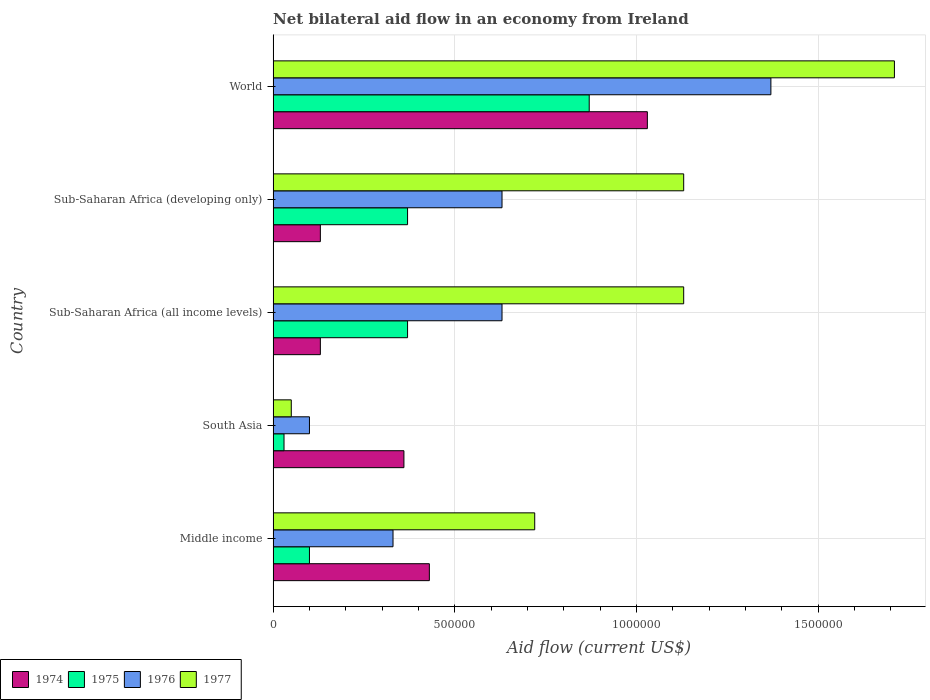How many bars are there on the 3rd tick from the top?
Keep it short and to the point. 4. In how many cases, is the number of bars for a given country not equal to the number of legend labels?
Make the answer very short. 0. What is the net bilateral aid flow in 1974 in World?
Offer a very short reply. 1.03e+06. Across all countries, what is the maximum net bilateral aid flow in 1976?
Offer a very short reply. 1.37e+06. Across all countries, what is the minimum net bilateral aid flow in 1974?
Offer a terse response. 1.30e+05. In which country was the net bilateral aid flow in 1976 maximum?
Ensure brevity in your answer.  World. In which country was the net bilateral aid flow in 1974 minimum?
Give a very brief answer. Sub-Saharan Africa (all income levels). What is the total net bilateral aid flow in 1974 in the graph?
Provide a short and direct response. 2.08e+06. What is the difference between the net bilateral aid flow in 1974 in South Asia and that in World?
Your response must be concise. -6.70e+05. What is the difference between the net bilateral aid flow in 1976 in South Asia and the net bilateral aid flow in 1975 in World?
Ensure brevity in your answer.  -7.70e+05. What is the average net bilateral aid flow in 1975 per country?
Ensure brevity in your answer.  3.48e+05. In how many countries, is the net bilateral aid flow in 1974 greater than 1500000 US$?
Offer a very short reply. 0. What is the ratio of the net bilateral aid flow in 1976 in Sub-Saharan Africa (all income levels) to that in Sub-Saharan Africa (developing only)?
Your answer should be very brief. 1. Is the difference between the net bilateral aid flow in 1977 in Sub-Saharan Africa (all income levels) and Sub-Saharan Africa (developing only) greater than the difference between the net bilateral aid flow in 1976 in Sub-Saharan Africa (all income levels) and Sub-Saharan Africa (developing only)?
Keep it short and to the point. No. What is the difference between the highest and the second highest net bilateral aid flow in 1977?
Your answer should be compact. 5.80e+05. What is the difference between the highest and the lowest net bilateral aid flow in 1977?
Your response must be concise. 1.66e+06. In how many countries, is the net bilateral aid flow in 1974 greater than the average net bilateral aid flow in 1974 taken over all countries?
Ensure brevity in your answer.  2. Is the sum of the net bilateral aid flow in 1976 in South Asia and World greater than the maximum net bilateral aid flow in 1977 across all countries?
Give a very brief answer. No. Is it the case that in every country, the sum of the net bilateral aid flow in 1976 and net bilateral aid flow in 1975 is greater than the sum of net bilateral aid flow in 1974 and net bilateral aid flow in 1977?
Provide a short and direct response. No. What does the 2nd bar from the top in Middle income represents?
Keep it short and to the point. 1976. Are all the bars in the graph horizontal?
Ensure brevity in your answer.  Yes. What is the difference between two consecutive major ticks on the X-axis?
Your response must be concise. 5.00e+05. Are the values on the major ticks of X-axis written in scientific E-notation?
Your answer should be very brief. No. Where does the legend appear in the graph?
Your answer should be very brief. Bottom left. What is the title of the graph?
Make the answer very short. Net bilateral aid flow in an economy from Ireland. Does "1981" appear as one of the legend labels in the graph?
Offer a terse response. No. What is the Aid flow (current US$) in 1976 in Middle income?
Give a very brief answer. 3.30e+05. What is the Aid flow (current US$) in 1977 in Middle income?
Keep it short and to the point. 7.20e+05. What is the Aid flow (current US$) of 1975 in South Asia?
Ensure brevity in your answer.  3.00e+04. What is the Aid flow (current US$) in 1976 in South Asia?
Provide a short and direct response. 1.00e+05. What is the Aid flow (current US$) in 1977 in South Asia?
Keep it short and to the point. 5.00e+04. What is the Aid flow (current US$) of 1974 in Sub-Saharan Africa (all income levels)?
Offer a terse response. 1.30e+05. What is the Aid flow (current US$) of 1976 in Sub-Saharan Africa (all income levels)?
Make the answer very short. 6.30e+05. What is the Aid flow (current US$) in 1977 in Sub-Saharan Africa (all income levels)?
Your answer should be very brief. 1.13e+06. What is the Aid flow (current US$) in 1976 in Sub-Saharan Africa (developing only)?
Ensure brevity in your answer.  6.30e+05. What is the Aid flow (current US$) of 1977 in Sub-Saharan Africa (developing only)?
Your answer should be very brief. 1.13e+06. What is the Aid flow (current US$) of 1974 in World?
Keep it short and to the point. 1.03e+06. What is the Aid flow (current US$) in 1975 in World?
Your answer should be compact. 8.70e+05. What is the Aid flow (current US$) in 1976 in World?
Provide a succinct answer. 1.37e+06. What is the Aid flow (current US$) in 1977 in World?
Your answer should be compact. 1.71e+06. Across all countries, what is the maximum Aid flow (current US$) in 1974?
Make the answer very short. 1.03e+06. Across all countries, what is the maximum Aid flow (current US$) of 1975?
Make the answer very short. 8.70e+05. Across all countries, what is the maximum Aid flow (current US$) of 1976?
Make the answer very short. 1.37e+06. Across all countries, what is the maximum Aid flow (current US$) of 1977?
Provide a short and direct response. 1.71e+06. What is the total Aid flow (current US$) in 1974 in the graph?
Offer a terse response. 2.08e+06. What is the total Aid flow (current US$) of 1975 in the graph?
Offer a terse response. 1.74e+06. What is the total Aid flow (current US$) of 1976 in the graph?
Your response must be concise. 3.06e+06. What is the total Aid flow (current US$) in 1977 in the graph?
Keep it short and to the point. 4.74e+06. What is the difference between the Aid flow (current US$) of 1976 in Middle income and that in South Asia?
Offer a terse response. 2.30e+05. What is the difference between the Aid flow (current US$) of 1977 in Middle income and that in South Asia?
Provide a short and direct response. 6.70e+05. What is the difference between the Aid flow (current US$) in 1974 in Middle income and that in Sub-Saharan Africa (all income levels)?
Your response must be concise. 3.00e+05. What is the difference between the Aid flow (current US$) of 1977 in Middle income and that in Sub-Saharan Africa (all income levels)?
Your answer should be very brief. -4.10e+05. What is the difference between the Aid flow (current US$) in 1977 in Middle income and that in Sub-Saharan Africa (developing only)?
Provide a short and direct response. -4.10e+05. What is the difference between the Aid flow (current US$) of 1974 in Middle income and that in World?
Your answer should be very brief. -6.00e+05. What is the difference between the Aid flow (current US$) of 1975 in Middle income and that in World?
Give a very brief answer. -7.70e+05. What is the difference between the Aid flow (current US$) in 1976 in Middle income and that in World?
Offer a very short reply. -1.04e+06. What is the difference between the Aid flow (current US$) in 1977 in Middle income and that in World?
Provide a succinct answer. -9.90e+05. What is the difference between the Aid flow (current US$) of 1976 in South Asia and that in Sub-Saharan Africa (all income levels)?
Offer a very short reply. -5.30e+05. What is the difference between the Aid flow (current US$) of 1977 in South Asia and that in Sub-Saharan Africa (all income levels)?
Provide a short and direct response. -1.08e+06. What is the difference between the Aid flow (current US$) of 1974 in South Asia and that in Sub-Saharan Africa (developing only)?
Offer a very short reply. 2.30e+05. What is the difference between the Aid flow (current US$) in 1975 in South Asia and that in Sub-Saharan Africa (developing only)?
Your answer should be very brief. -3.40e+05. What is the difference between the Aid flow (current US$) in 1976 in South Asia and that in Sub-Saharan Africa (developing only)?
Your answer should be compact. -5.30e+05. What is the difference between the Aid flow (current US$) in 1977 in South Asia and that in Sub-Saharan Africa (developing only)?
Provide a short and direct response. -1.08e+06. What is the difference between the Aid flow (current US$) of 1974 in South Asia and that in World?
Make the answer very short. -6.70e+05. What is the difference between the Aid flow (current US$) in 1975 in South Asia and that in World?
Provide a succinct answer. -8.40e+05. What is the difference between the Aid flow (current US$) in 1976 in South Asia and that in World?
Offer a terse response. -1.27e+06. What is the difference between the Aid flow (current US$) of 1977 in South Asia and that in World?
Give a very brief answer. -1.66e+06. What is the difference between the Aid flow (current US$) in 1974 in Sub-Saharan Africa (all income levels) and that in Sub-Saharan Africa (developing only)?
Your answer should be compact. 0. What is the difference between the Aid flow (current US$) of 1974 in Sub-Saharan Africa (all income levels) and that in World?
Offer a terse response. -9.00e+05. What is the difference between the Aid flow (current US$) in 1975 in Sub-Saharan Africa (all income levels) and that in World?
Provide a succinct answer. -5.00e+05. What is the difference between the Aid flow (current US$) in 1976 in Sub-Saharan Africa (all income levels) and that in World?
Your answer should be very brief. -7.40e+05. What is the difference between the Aid flow (current US$) in 1977 in Sub-Saharan Africa (all income levels) and that in World?
Keep it short and to the point. -5.80e+05. What is the difference between the Aid flow (current US$) of 1974 in Sub-Saharan Africa (developing only) and that in World?
Give a very brief answer. -9.00e+05. What is the difference between the Aid flow (current US$) of 1975 in Sub-Saharan Africa (developing only) and that in World?
Offer a terse response. -5.00e+05. What is the difference between the Aid flow (current US$) of 1976 in Sub-Saharan Africa (developing only) and that in World?
Keep it short and to the point. -7.40e+05. What is the difference between the Aid flow (current US$) in 1977 in Sub-Saharan Africa (developing only) and that in World?
Make the answer very short. -5.80e+05. What is the difference between the Aid flow (current US$) in 1974 in Middle income and the Aid flow (current US$) in 1975 in South Asia?
Give a very brief answer. 4.00e+05. What is the difference between the Aid flow (current US$) in 1975 in Middle income and the Aid flow (current US$) in 1977 in South Asia?
Your response must be concise. 5.00e+04. What is the difference between the Aid flow (current US$) in 1976 in Middle income and the Aid flow (current US$) in 1977 in South Asia?
Keep it short and to the point. 2.80e+05. What is the difference between the Aid flow (current US$) in 1974 in Middle income and the Aid flow (current US$) in 1975 in Sub-Saharan Africa (all income levels)?
Provide a short and direct response. 6.00e+04. What is the difference between the Aid flow (current US$) in 1974 in Middle income and the Aid flow (current US$) in 1976 in Sub-Saharan Africa (all income levels)?
Your answer should be very brief. -2.00e+05. What is the difference between the Aid flow (current US$) of 1974 in Middle income and the Aid flow (current US$) of 1977 in Sub-Saharan Africa (all income levels)?
Give a very brief answer. -7.00e+05. What is the difference between the Aid flow (current US$) in 1975 in Middle income and the Aid flow (current US$) in 1976 in Sub-Saharan Africa (all income levels)?
Your answer should be compact. -5.30e+05. What is the difference between the Aid flow (current US$) in 1975 in Middle income and the Aid flow (current US$) in 1977 in Sub-Saharan Africa (all income levels)?
Give a very brief answer. -1.03e+06. What is the difference between the Aid flow (current US$) in 1976 in Middle income and the Aid flow (current US$) in 1977 in Sub-Saharan Africa (all income levels)?
Offer a terse response. -8.00e+05. What is the difference between the Aid flow (current US$) in 1974 in Middle income and the Aid flow (current US$) in 1977 in Sub-Saharan Africa (developing only)?
Ensure brevity in your answer.  -7.00e+05. What is the difference between the Aid flow (current US$) of 1975 in Middle income and the Aid flow (current US$) of 1976 in Sub-Saharan Africa (developing only)?
Give a very brief answer. -5.30e+05. What is the difference between the Aid flow (current US$) in 1975 in Middle income and the Aid flow (current US$) in 1977 in Sub-Saharan Africa (developing only)?
Your response must be concise. -1.03e+06. What is the difference between the Aid flow (current US$) of 1976 in Middle income and the Aid flow (current US$) of 1977 in Sub-Saharan Africa (developing only)?
Ensure brevity in your answer.  -8.00e+05. What is the difference between the Aid flow (current US$) of 1974 in Middle income and the Aid flow (current US$) of 1975 in World?
Offer a terse response. -4.40e+05. What is the difference between the Aid flow (current US$) of 1974 in Middle income and the Aid flow (current US$) of 1976 in World?
Your response must be concise. -9.40e+05. What is the difference between the Aid flow (current US$) of 1974 in Middle income and the Aid flow (current US$) of 1977 in World?
Ensure brevity in your answer.  -1.28e+06. What is the difference between the Aid flow (current US$) in 1975 in Middle income and the Aid flow (current US$) in 1976 in World?
Keep it short and to the point. -1.27e+06. What is the difference between the Aid flow (current US$) in 1975 in Middle income and the Aid flow (current US$) in 1977 in World?
Provide a short and direct response. -1.61e+06. What is the difference between the Aid flow (current US$) in 1976 in Middle income and the Aid flow (current US$) in 1977 in World?
Offer a terse response. -1.38e+06. What is the difference between the Aid flow (current US$) in 1974 in South Asia and the Aid flow (current US$) in 1977 in Sub-Saharan Africa (all income levels)?
Your answer should be very brief. -7.70e+05. What is the difference between the Aid flow (current US$) in 1975 in South Asia and the Aid flow (current US$) in 1976 in Sub-Saharan Africa (all income levels)?
Provide a short and direct response. -6.00e+05. What is the difference between the Aid flow (current US$) in 1975 in South Asia and the Aid flow (current US$) in 1977 in Sub-Saharan Africa (all income levels)?
Your response must be concise. -1.10e+06. What is the difference between the Aid flow (current US$) in 1976 in South Asia and the Aid flow (current US$) in 1977 in Sub-Saharan Africa (all income levels)?
Your answer should be compact. -1.03e+06. What is the difference between the Aid flow (current US$) in 1974 in South Asia and the Aid flow (current US$) in 1975 in Sub-Saharan Africa (developing only)?
Ensure brevity in your answer.  -10000. What is the difference between the Aid flow (current US$) in 1974 in South Asia and the Aid flow (current US$) in 1976 in Sub-Saharan Africa (developing only)?
Your response must be concise. -2.70e+05. What is the difference between the Aid flow (current US$) of 1974 in South Asia and the Aid flow (current US$) of 1977 in Sub-Saharan Africa (developing only)?
Your response must be concise. -7.70e+05. What is the difference between the Aid flow (current US$) of 1975 in South Asia and the Aid flow (current US$) of 1976 in Sub-Saharan Africa (developing only)?
Your answer should be compact. -6.00e+05. What is the difference between the Aid flow (current US$) in 1975 in South Asia and the Aid flow (current US$) in 1977 in Sub-Saharan Africa (developing only)?
Your response must be concise. -1.10e+06. What is the difference between the Aid flow (current US$) in 1976 in South Asia and the Aid flow (current US$) in 1977 in Sub-Saharan Africa (developing only)?
Keep it short and to the point. -1.03e+06. What is the difference between the Aid flow (current US$) of 1974 in South Asia and the Aid flow (current US$) of 1975 in World?
Your answer should be very brief. -5.10e+05. What is the difference between the Aid flow (current US$) in 1974 in South Asia and the Aid flow (current US$) in 1976 in World?
Provide a short and direct response. -1.01e+06. What is the difference between the Aid flow (current US$) in 1974 in South Asia and the Aid flow (current US$) in 1977 in World?
Provide a short and direct response. -1.35e+06. What is the difference between the Aid flow (current US$) of 1975 in South Asia and the Aid flow (current US$) of 1976 in World?
Offer a very short reply. -1.34e+06. What is the difference between the Aid flow (current US$) in 1975 in South Asia and the Aid flow (current US$) in 1977 in World?
Ensure brevity in your answer.  -1.68e+06. What is the difference between the Aid flow (current US$) in 1976 in South Asia and the Aid flow (current US$) in 1977 in World?
Give a very brief answer. -1.61e+06. What is the difference between the Aid flow (current US$) of 1974 in Sub-Saharan Africa (all income levels) and the Aid flow (current US$) of 1975 in Sub-Saharan Africa (developing only)?
Keep it short and to the point. -2.40e+05. What is the difference between the Aid flow (current US$) of 1974 in Sub-Saharan Africa (all income levels) and the Aid flow (current US$) of 1976 in Sub-Saharan Africa (developing only)?
Your response must be concise. -5.00e+05. What is the difference between the Aid flow (current US$) in 1975 in Sub-Saharan Africa (all income levels) and the Aid flow (current US$) in 1977 in Sub-Saharan Africa (developing only)?
Provide a short and direct response. -7.60e+05. What is the difference between the Aid flow (current US$) in 1976 in Sub-Saharan Africa (all income levels) and the Aid flow (current US$) in 1977 in Sub-Saharan Africa (developing only)?
Your response must be concise. -5.00e+05. What is the difference between the Aid flow (current US$) of 1974 in Sub-Saharan Africa (all income levels) and the Aid flow (current US$) of 1975 in World?
Ensure brevity in your answer.  -7.40e+05. What is the difference between the Aid flow (current US$) of 1974 in Sub-Saharan Africa (all income levels) and the Aid flow (current US$) of 1976 in World?
Your answer should be very brief. -1.24e+06. What is the difference between the Aid flow (current US$) in 1974 in Sub-Saharan Africa (all income levels) and the Aid flow (current US$) in 1977 in World?
Keep it short and to the point. -1.58e+06. What is the difference between the Aid flow (current US$) in 1975 in Sub-Saharan Africa (all income levels) and the Aid flow (current US$) in 1976 in World?
Your answer should be very brief. -1.00e+06. What is the difference between the Aid flow (current US$) of 1975 in Sub-Saharan Africa (all income levels) and the Aid flow (current US$) of 1977 in World?
Offer a very short reply. -1.34e+06. What is the difference between the Aid flow (current US$) in 1976 in Sub-Saharan Africa (all income levels) and the Aid flow (current US$) in 1977 in World?
Ensure brevity in your answer.  -1.08e+06. What is the difference between the Aid flow (current US$) in 1974 in Sub-Saharan Africa (developing only) and the Aid flow (current US$) in 1975 in World?
Your response must be concise. -7.40e+05. What is the difference between the Aid flow (current US$) in 1974 in Sub-Saharan Africa (developing only) and the Aid flow (current US$) in 1976 in World?
Provide a succinct answer. -1.24e+06. What is the difference between the Aid flow (current US$) of 1974 in Sub-Saharan Africa (developing only) and the Aid flow (current US$) of 1977 in World?
Provide a short and direct response. -1.58e+06. What is the difference between the Aid flow (current US$) of 1975 in Sub-Saharan Africa (developing only) and the Aid flow (current US$) of 1977 in World?
Keep it short and to the point. -1.34e+06. What is the difference between the Aid flow (current US$) of 1976 in Sub-Saharan Africa (developing only) and the Aid flow (current US$) of 1977 in World?
Make the answer very short. -1.08e+06. What is the average Aid flow (current US$) of 1974 per country?
Provide a succinct answer. 4.16e+05. What is the average Aid flow (current US$) in 1975 per country?
Your answer should be very brief. 3.48e+05. What is the average Aid flow (current US$) in 1976 per country?
Keep it short and to the point. 6.12e+05. What is the average Aid flow (current US$) in 1977 per country?
Your answer should be compact. 9.48e+05. What is the difference between the Aid flow (current US$) of 1974 and Aid flow (current US$) of 1975 in Middle income?
Your response must be concise. 3.30e+05. What is the difference between the Aid flow (current US$) of 1975 and Aid flow (current US$) of 1976 in Middle income?
Your answer should be very brief. -2.30e+05. What is the difference between the Aid flow (current US$) in 1975 and Aid flow (current US$) in 1977 in Middle income?
Your response must be concise. -6.20e+05. What is the difference between the Aid flow (current US$) in 1976 and Aid flow (current US$) in 1977 in Middle income?
Keep it short and to the point. -3.90e+05. What is the difference between the Aid flow (current US$) of 1974 and Aid flow (current US$) of 1975 in South Asia?
Give a very brief answer. 3.30e+05. What is the difference between the Aid flow (current US$) in 1974 and Aid flow (current US$) in 1976 in South Asia?
Give a very brief answer. 2.60e+05. What is the difference between the Aid flow (current US$) of 1975 and Aid flow (current US$) of 1976 in South Asia?
Your answer should be compact. -7.00e+04. What is the difference between the Aid flow (current US$) in 1974 and Aid flow (current US$) in 1975 in Sub-Saharan Africa (all income levels)?
Provide a succinct answer. -2.40e+05. What is the difference between the Aid flow (current US$) in 1974 and Aid flow (current US$) in 1976 in Sub-Saharan Africa (all income levels)?
Offer a very short reply. -5.00e+05. What is the difference between the Aid flow (current US$) of 1974 and Aid flow (current US$) of 1977 in Sub-Saharan Africa (all income levels)?
Your answer should be compact. -1.00e+06. What is the difference between the Aid flow (current US$) of 1975 and Aid flow (current US$) of 1977 in Sub-Saharan Africa (all income levels)?
Ensure brevity in your answer.  -7.60e+05. What is the difference between the Aid flow (current US$) of 1976 and Aid flow (current US$) of 1977 in Sub-Saharan Africa (all income levels)?
Provide a short and direct response. -5.00e+05. What is the difference between the Aid flow (current US$) in 1974 and Aid flow (current US$) in 1975 in Sub-Saharan Africa (developing only)?
Make the answer very short. -2.40e+05. What is the difference between the Aid flow (current US$) in 1974 and Aid flow (current US$) in 1976 in Sub-Saharan Africa (developing only)?
Keep it short and to the point. -5.00e+05. What is the difference between the Aid flow (current US$) of 1975 and Aid flow (current US$) of 1977 in Sub-Saharan Africa (developing only)?
Offer a very short reply. -7.60e+05. What is the difference between the Aid flow (current US$) of 1976 and Aid flow (current US$) of 1977 in Sub-Saharan Africa (developing only)?
Your response must be concise. -5.00e+05. What is the difference between the Aid flow (current US$) in 1974 and Aid flow (current US$) in 1975 in World?
Offer a terse response. 1.60e+05. What is the difference between the Aid flow (current US$) of 1974 and Aid flow (current US$) of 1976 in World?
Keep it short and to the point. -3.40e+05. What is the difference between the Aid flow (current US$) of 1974 and Aid flow (current US$) of 1977 in World?
Ensure brevity in your answer.  -6.80e+05. What is the difference between the Aid flow (current US$) in 1975 and Aid flow (current US$) in 1976 in World?
Your answer should be very brief. -5.00e+05. What is the difference between the Aid flow (current US$) in 1975 and Aid flow (current US$) in 1977 in World?
Your answer should be very brief. -8.40e+05. What is the ratio of the Aid flow (current US$) of 1974 in Middle income to that in South Asia?
Your answer should be very brief. 1.19. What is the ratio of the Aid flow (current US$) in 1976 in Middle income to that in South Asia?
Your answer should be compact. 3.3. What is the ratio of the Aid flow (current US$) of 1974 in Middle income to that in Sub-Saharan Africa (all income levels)?
Offer a terse response. 3.31. What is the ratio of the Aid flow (current US$) in 1975 in Middle income to that in Sub-Saharan Africa (all income levels)?
Your response must be concise. 0.27. What is the ratio of the Aid flow (current US$) in 1976 in Middle income to that in Sub-Saharan Africa (all income levels)?
Keep it short and to the point. 0.52. What is the ratio of the Aid flow (current US$) in 1977 in Middle income to that in Sub-Saharan Africa (all income levels)?
Your response must be concise. 0.64. What is the ratio of the Aid flow (current US$) of 1974 in Middle income to that in Sub-Saharan Africa (developing only)?
Your answer should be compact. 3.31. What is the ratio of the Aid flow (current US$) in 1975 in Middle income to that in Sub-Saharan Africa (developing only)?
Give a very brief answer. 0.27. What is the ratio of the Aid flow (current US$) in 1976 in Middle income to that in Sub-Saharan Africa (developing only)?
Provide a succinct answer. 0.52. What is the ratio of the Aid flow (current US$) in 1977 in Middle income to that in Sub-Saharan Africa (developing only)?
Your response must be concise. 0.64. What is the ratio of the Aid flow (current US$) of 1974 in Middle income to that in World?
Make the answer very short. 0.42. What is the ratio of the Aid flow (current US$) of 1975 in Middle income to that in World?
Keep it short and to the point. 0.11. What is the ratio of the Aid flow (current US$) in 1976 in Middle income to that in World?
Your answer should be compact. 0.24. What is the ratio of the Aid flow (current US$) in 1977 in Middle income to that in World?
Keep it short and to the point. 0.42. What is the ratio of the Aid flow (current US$) in 1974 in South Asia to that in Sub-Saharan Africa (all income levels)?
Provide a succinct answer. 2.77. What is the ratio of the Aid flow (current US$) in 1975 in South Asia to that in Sub-Saharan Africa (all income levels)?
Ensure brevity in your answer.  0.08. What is the ratio of the Aid flow (current US$) in 1976 in South Asia to that in Sub-Saharan Africa (all income levels)?
Provide a succinct answer. 0.16. What is the ratio of the Aid flow (current US$) of 1977 in South Asia to that in Sub-Saharan Africa (all income levels)?
Ensure brevity in your answer.  0.04. What is the ratio of the Aid flow (current US$) of 1974 in South Asia to that in Sub-Saharan Africa (developing only)?
Offer a very short reply. 2.77. What is the ratio of the Aid flow (current US$) of 1975 in South Asia to that in Sub-Saharan Africa (developing only)?
Give a very brief answer. 0.08. What is the ratio of the Aid flow (current US$) in 1976 in South Asia to that in Sub-Saharan Africa (developing only)?
Ensure brevity in your answer.  0.16. What is the ratio of the Aid flow (current US$) in 1977 in South Asia to that in Sub-Saharan Africa (developing only)?
Keep it short and to the point. 0.04. What is the ratio of the Aid flow (current US$) of 1974 in South Asia to that in World?
Ensure brevity in your answer.  0.35. What is the ratio of the Aid flow (current US$) in 1975 in South Asia to that in World?
Keep it short and to the point. 0.03. What is the ratio of the Aid flow (current US$) in 1976 in South Asia to that in World?
Give a very brief answer. 0.07. What is the ratio of the Aid flow (current US$) in 1977 in South Asia to that in World?
Your response must be concise. 0.03. What is the ratio of the Aid flow (current US$) of 1976 in Sub-Saharan Africa (all income levels) to that in Sub-Saharan Africa (developing only)?
Your answer should be compact. 1. What is the ratio of the Aid flow (current US$) of 1977 in Sub-Saharan Africa (all income levels) to that in Sub-Saharan Africa (developing only)?
Make the answer very short. 1. What is the ratio of the Aid flow (current US$) of 1974 in Sub-Saharan Africa (all income levels) to that in World?
Your answer should be compact. 0.13. What is the ratio of the Aid flow (current US$) of 1975 in Sub-Saharan Africa (all income levels) to that in World?
Your answer should be very brief. 0.43. What is the ratio of the Aid flow (current US$) of 1976 in Sub-Saharan Africa (all income levels) to that in World?
Offer a very short reply. 0.46. What is the ratio of the Aid flow (current US$) of 1977 in Sub-Saharan Africa (all income levels) to that in World?
Offer a terse response. 0.66. What is the ratio of the Aid flow (current US$) in 1974 in Sub-Saharan Africa (developing only) to that in World?
Provide a short and direct response. 0.13. What is the ratio of the Aid flow (current US$) of 1975 in Sub-Saharan Africa (developing only) to that in World?
Provide a succinct answer. 0.43. What is the ratio of the Aid flow (current US$) in 1976 in Sub-Saharan Africa (developing only) to that in World?
Your response must be concise. 0.46. What is the ratio of the Aid flow (current US$) in 1977 in Sub-Saharan Africa (developing only) to that in World?
Ensure brevity in your answer.  0.66. What is the difference between the highest and the second highest Aid flow (current US$) in 1974?
Your answer should be very brief. 6.00e+05. What is the difference between the highest and the second highest Aid flow (current US$) of 1976?
Provide a short and direct response. 7.40e+05. What is the difference between the highest and the second highest Aid flow (current US$) in 1977?
Keep it short and to the point. 5.80e+05. What is the difference between the highest and the lowest Aid flow (current US$) of 1975?
Keep it short and to the point. 8.40e+05. What is the difference between the highest and the lowest Aid flow (current US$) of 1976?
Your answer should be very brief. 1.27e+06. What is the difference between the highest and the lowest Aid flow (current US$) of 1977?
Your response must be concise. 1.66e+06. 